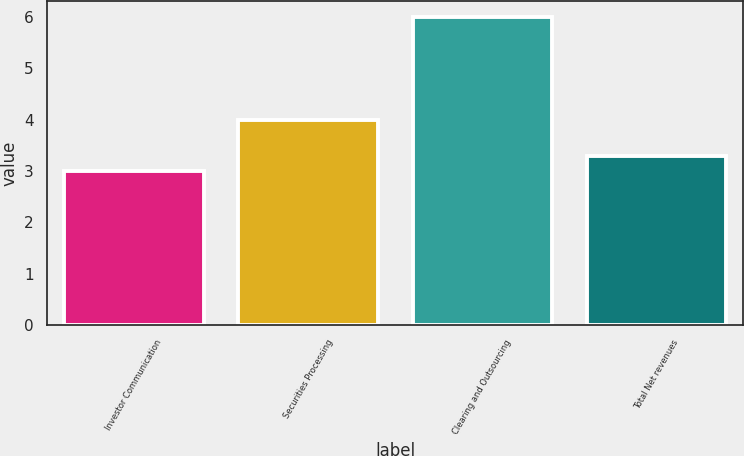Convert chart to OTSL. <chart><loc_0><loc_0><loc_500><loc_500><bar_chart><fcel>Investor Communication<fcel>Securities Processing<fcel>Clearing and Outsourcing<fcel>Total Net revenues<nl><fcel>3<fcel>4<fcel>6<fcel>3.3<nl></chart> 